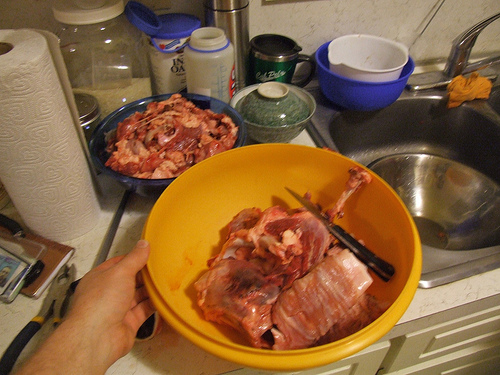<image>
Is there a knife in the bowl? Yes. The knife is contained within or inside the bowl, showing a containment relationship. 